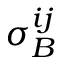Convert formula to latex. <formula><loc_0><loc_0><loc_500><loc_500>\sigma _ { B } ^ { i j }</formula> 